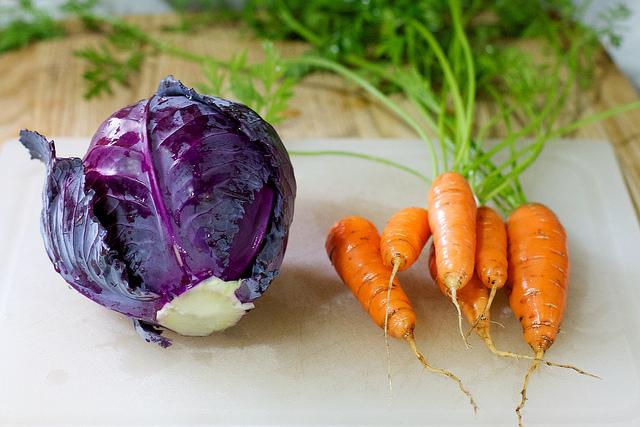What are the vegetables sitting on?
Answer briefly. Cutting board. Have the carrots been peeled?
Short answer required. No. What is the purple vegetable called?
Quick response, please. Cabbage. 